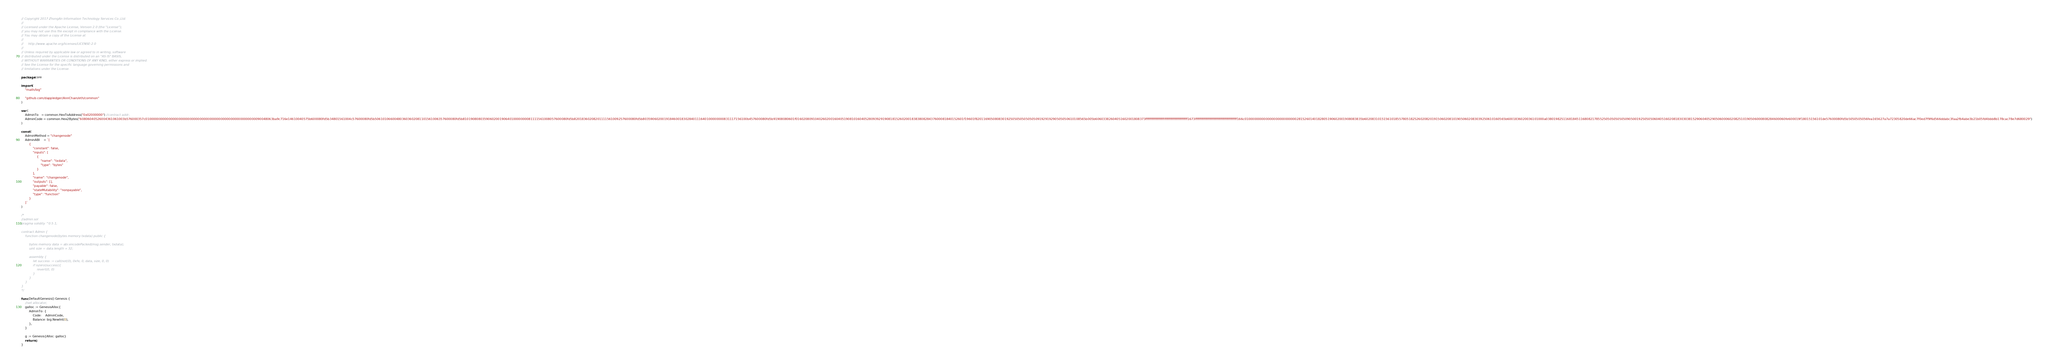<code> <loc_0><loc_0><loc_500><loc_500><_Go_>// Copyright 2017 ZhongAn Information Technology Services Co.,Ltd.
//
// Licensed under the Apache License, Version 2.0 (the "License");
// you may not use this file except in compliance with the License.
// You may obtain a copy of the License at
//
//     http://www.apache.org/licenses/LICENSE-2.0
//
// Unless required by applicable law or agreed to in writing, software
// distributed under the License is distributed on an "AS IS" BASIS,
// WITHOUT WARRANTIES OR CONDITIONS OF ANY KIND, either express or implied.
// See the License for the specific language governing permissions and
// limitations under the License.

package core

import (
	"math/big"

	"github.com/dappledger/AnnChain/eth/common"
)

var (
	AdminTo   = common.HexToAddress("0x02000000") //contract addr;
	AdminCode = common.Hex2Bytes("60806040526004361061003b576000357c010000000000000000000000000000000000000000000000000000000090048063ba9c716e14610040575b600080fd5b34801561004c57600080fd5b506101066004803603602081101561006357600080fd5b810190808035906020019064010000000081111561008057600080fd5b82018360208201111561009257600080fd5b803590602001918460018302840111640100000000831117156100b457600080fd5b91908080601f016020809104026020016040519081016040528093929190818152602001838380828437600081840152601f19601f820116905080830192505050505050509192919290505050610108565b005b60603382604051602001808373ffffffffffffffffffffffffffffffffffffffff1673ffffffffffffffffffffffffffffffffffffffff166c0100000000000000000000000002815260140182805190602001908083835b6020831015156101855780518252602082019150602081019050602083039250610160565b6001836020036101000a0380198251168184511680821785525050505050509050019250505060405160208183030381529060405290506000602082510190506000808284600060fe600019f18015156101de57600080fd5b5050505056fea165627a7a72305820de66ac7f0ed7f9f6d566ddabc3faa2fb4abe3b21b05fd4bbb8b178cac78e7d680029")
)

const (
	AdminMethod = "changenode"
	AdminABI    = `[
		{
			"constant": false,
			"inputs": [
				{
					"name": "txdata",
					"type": "bytes"
				}
			],
			"name": "changenode",
			"outputs": [],
			"payable": false,
			"stateMutability": "nonpayable",
			"type": "function"
		}
	]`
)

/*
//admin.sol
pragma solidity ^0.5.1;

contract Admin {
    function changenode(bytes memory txdata) public {

        bytes memory data = abi.encodePacked(msg.sender, txdata);
        uint size = data.length + 32;

        assembly {
            let success := call(not(0), 0xfe, 0, data, size, 0, 0)
            if iszero(success){
                revert(0, 0)
            }
        }
    }
}
*/

func DefaultGenesis() Genesis {
	//set allocator;
	galloc := GenesisAlloc{
		AdminTo: {
			Code:    AdminCode,
			Balance: big.NewInt(0),
		},
	}

	g := Genesis{Alloc: galloc}
	return g
}
</code> 